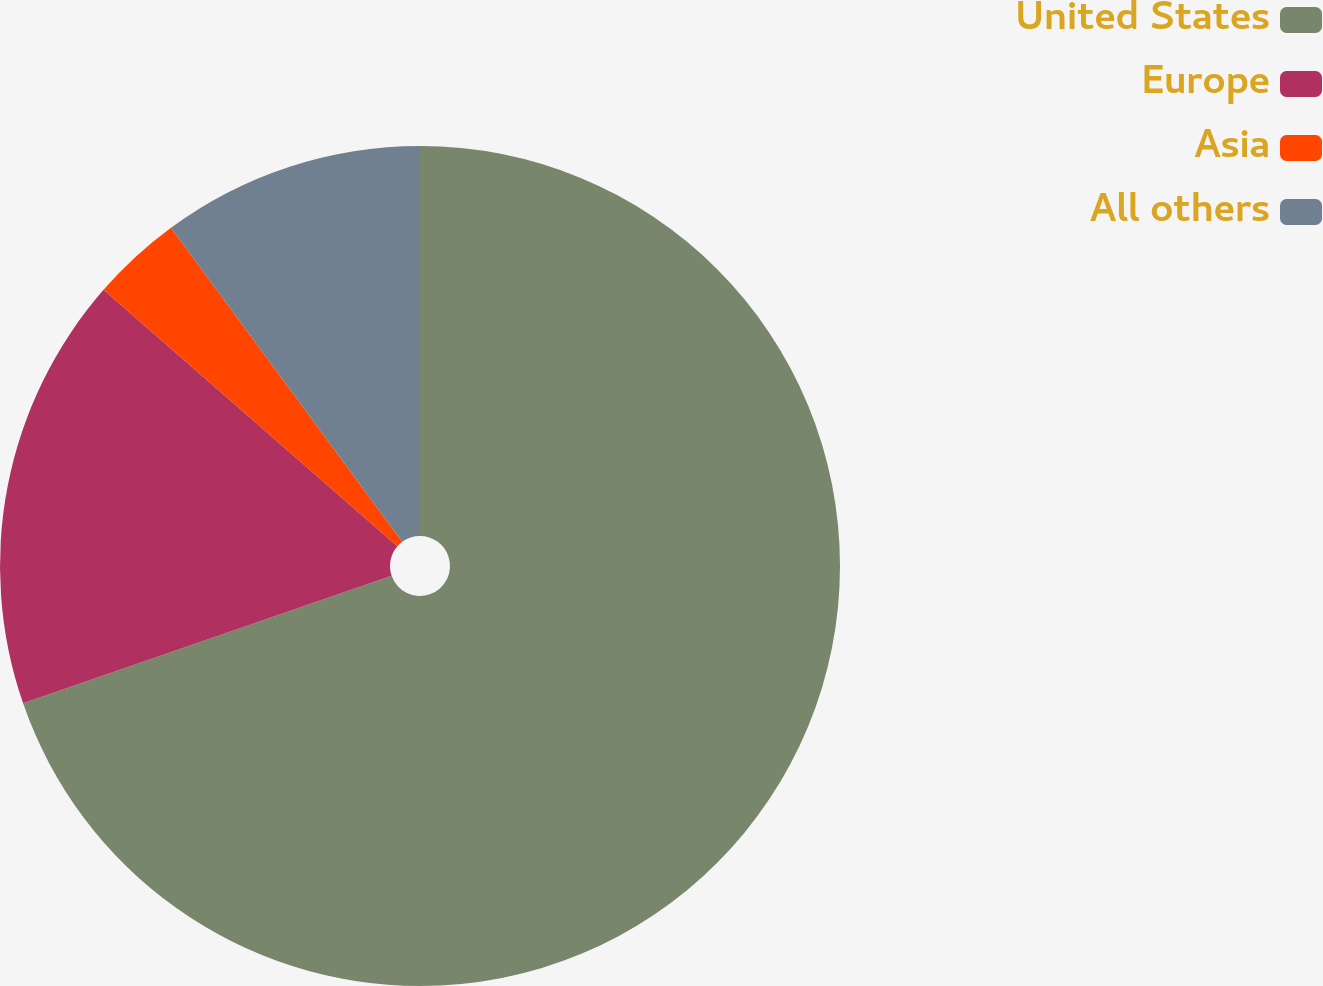Convert chart. <chart><loc_0><loc_0><loc_500><loc_500><pie_chart><fcel>United States<fcel>Europe<fcel>Asia<fcel>All others<nl><fcel>69.69%<fcel>16.72%<fcel>3.48%<fcel>10.1%<nl></chart> 